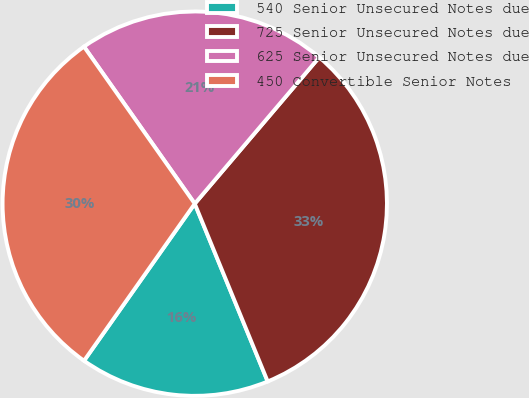Convert chart to OTSL. <chart><loc_0><loc_0><loc_500><loc_500><pie_chart><fcel>540 Senior Unsecured Notes due<fcel>725 Senior Unsecured Notes due<fcel>625 Senior Unsecured Notes due<fcel>450 Convertible Senior Notes<nl><fcel>15.97%<fcel>32.59%<fcel>20.99%<fcel>30.45%<nl></chart> 